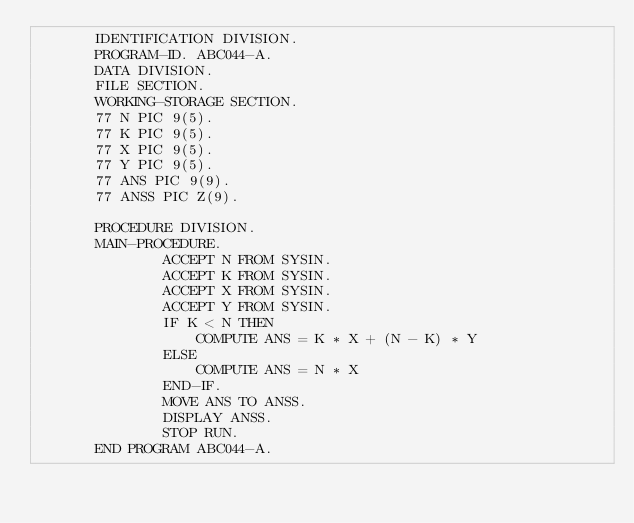Convert code to text. <code><loc_0><loc_0><loc_500><loc_500><_COBOL_>       IDENTIFICATION DIVISION.
       PROGRAM-ID. ABC044-A.
       DATA DIVISION.
       FILE SECTION.
       WORKING-STORAGE SECTION.
       77 N PIC 9(5).
       77 K PIC 9(5).
       77 X PIC 9(5).
       77 Y PIC 9(5).
       77 ANS PIC 9(9).
       77 ANSS PIC Z(9).

       PROCEDURE DIVISION.
       MAIN-PROCEDURE.
               ACCEPT N FROM SYSIN.
               ACCEPT K FROM SYSIN.
               ACCEPT X FROM SYSIN.
               ACCEPT Y FROM SYSIN.
               IF K < N THEN
                   COMPUTE ANS = K * X + (N - K) * Y
               ELSE
                   COMPUTE ANS = N * X
               END-IF.
               MOVE ANS TO ANSS.
               DISPLAY ANSS.
               STOP RUN.
       END PROGRAM ABC044-A.
</code> 